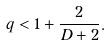Convert formula to latex. <formula><loc_0><loc_0><loc_500><loc_500>q < 1 + \frac { 2 } { D + 2 } .</formula> 